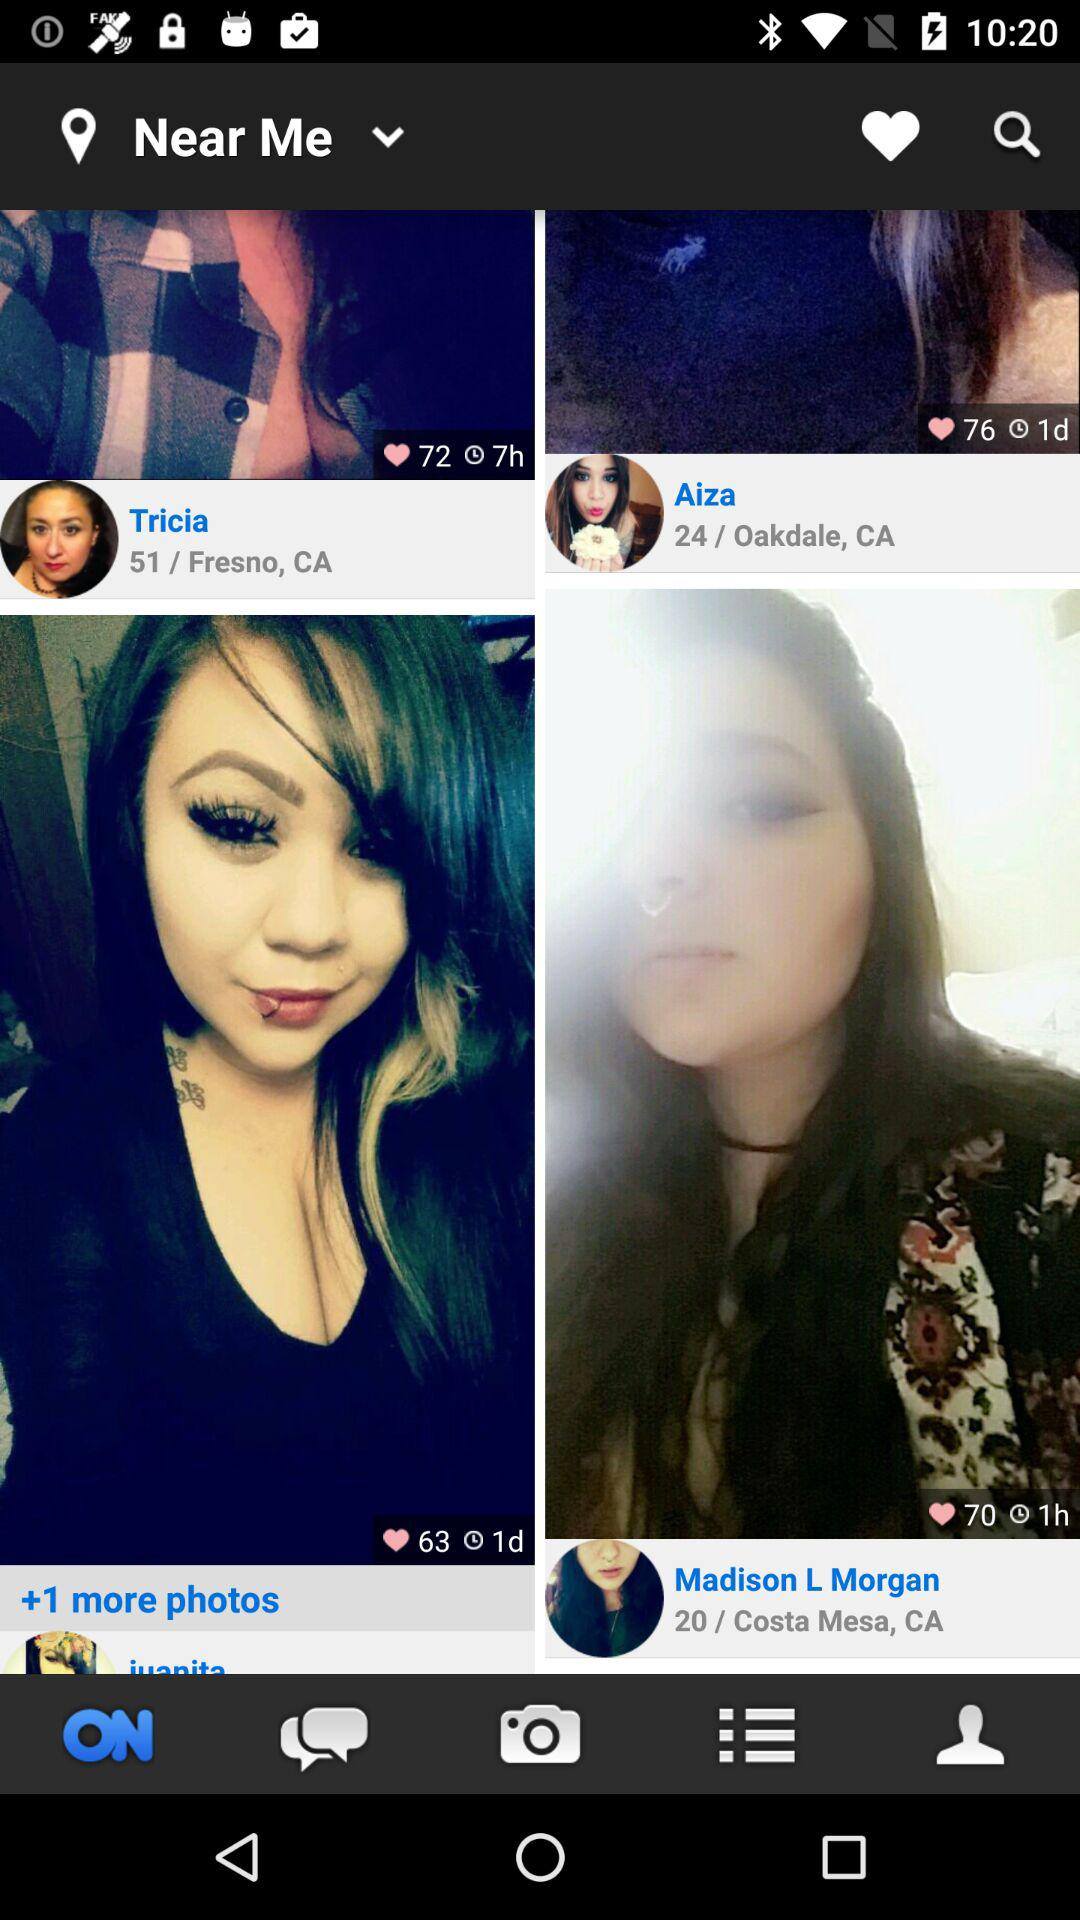What place belongs to Tricia? Tricia belongs to Fresno, CA. 